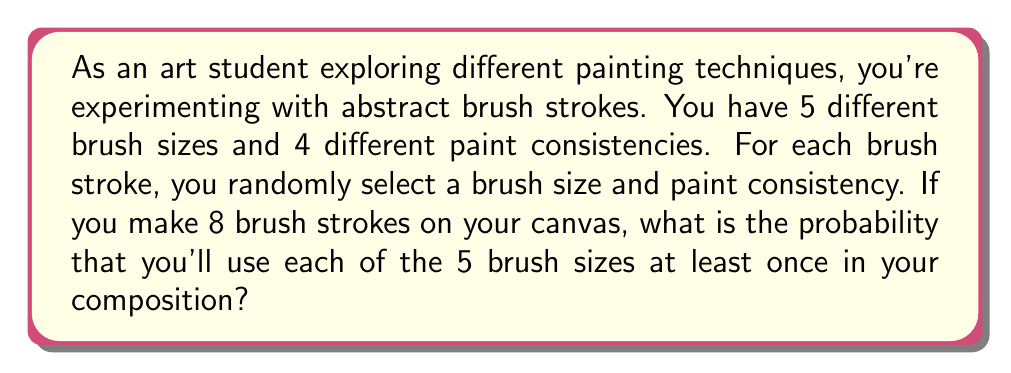Can you answer this question? Let's approach this step-by-step using probability theory:

1) First, we need to calculate the total number of possible outcomes when making 8 brush strokes. For each stroke, we have 5 choices for brush size and 4 for paint consistency, so:

   Total outcomes = $$(5 \times 4)^8 = 20^8$$

2) Now, we need to calculate the number of favorable outcomes (where all 5 brush sizes are used at least once). It's easier to calculate this indirectly:

   Favorable outcomes = Total outcomes - Unfavorable outcomes

3) Unfavorable outcomes are those where at least one brush size is not used. We can calculate this using the Inclusion-Exclusion Principle:

   $$\text{Unfavorable} = \binom{5}{1}(4^4)^8 - \binom{5}{2}(3^4)^8 + \binom{5}{3}(2^4)^8 - \binom{5}{4}(1^4)^8$$

   Where:
   - $\binom{5}{1}(4^4)^8$ counts outcomes missing 1 brush size
   - $\binom{5}{2}(3^4)^8$ counts outcomes missing 2 brush sizes
   - $\binom{5}{3}(2^4)^8$ counts outcomes missing 3 brush sizes
   - $\binom{5}{4}(1^4)^8$ counts outcomes missing 4 brush sizes

4) Calculating:
   $$\text{Unfavorable} = 5(4^4)^8 - 10(3^4)^8 + 10(2^4)^8 - 5(1^4)^8$$
   $$= 5(256^8) - 10(81^8) + 10(16^8) - 5(1^8)$$
   $$= 5(1.8447 \times 10^{19}) - 10(2.3075 \times 10^{15}) + 10(4.2950 \times 10^9) - 5$$

5) Now we can calculate the probability:

   $$P(\text{all 5 brush sizes}) = \frac{\text{Favorable outcomes}}{\text{Total outcomes}}$$
   $$= \frac{\text{Total outcomes} - \text{Unfavorable outcomes}}{\text{Total outcomes}}$$
   $$= 1 - \frac{\text{Unfavorable outcomes}}{\text{Total outcomes}}$$
   $$= 1 - \frac{5(1.8447 \times 10^{19}) - 10(2.3075 \times 10^{15}) + 10(4.2950 \times 10^9) - 5}{20^8}$$
Answer: The probability of using all 5 brush sizes at least once in 8 brush strokes is approximately 0.7055 or 70.55%. 